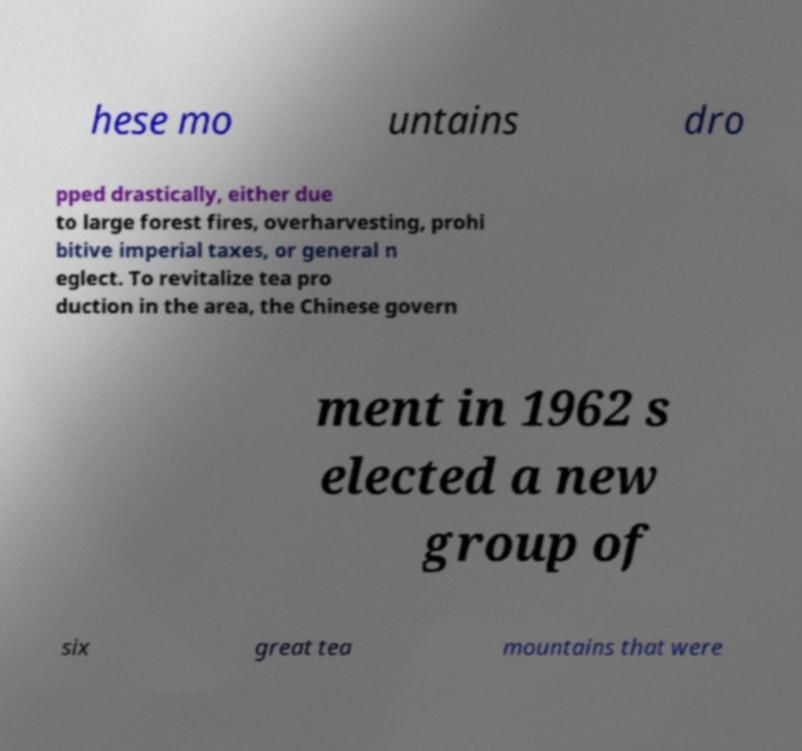Please read and relay the text visible in this image. What does it say? hese mo untains dro pped drastically, either due to large forest fires, overharvesting, prohi bitive imperial taxes, or general n eglect. To revitalize tea pro duction in the area, the Chinese govern ment in 1962 s elected a new group of six great tea mountains that were 